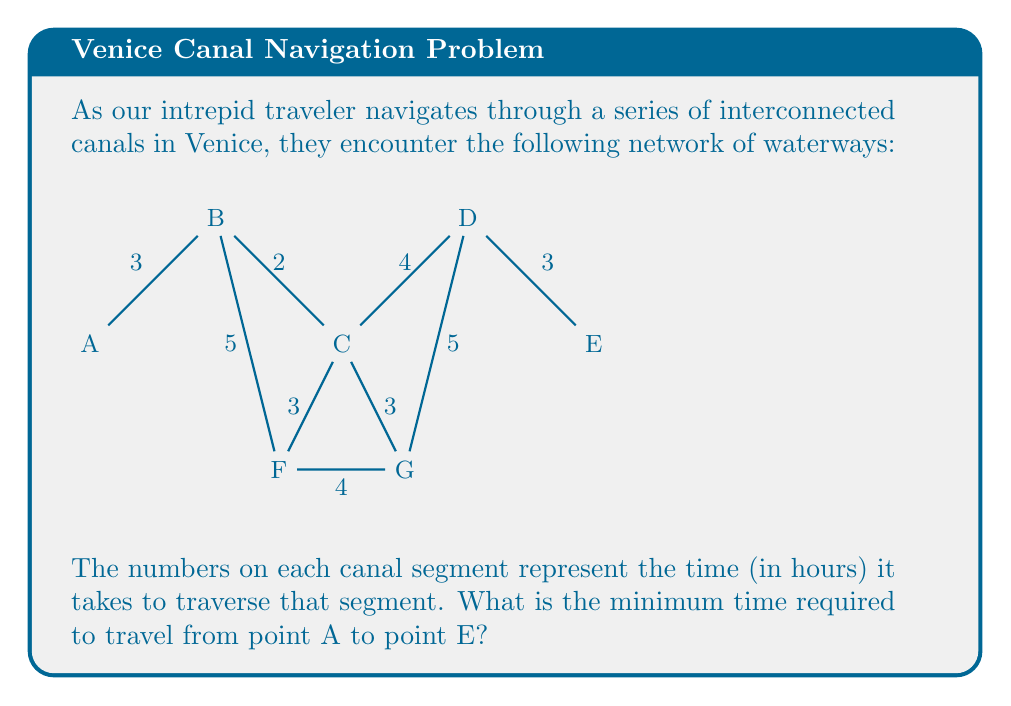Can you solve this math problem? To solve this problem, we need to find the shortest path from A to E. We can use Dijkstra's algorithm or simply evaluate all possible paths:

1) Path A-B-C-D-E: 
   $$3 + 2 + 4 + 3 = 12$$ hours

2) Path A-B-F-G-D-E: 
   $$3 + 5 + 4 + 5 + 3 = 20$$ hours

3) Path A-B-C-F-G-D-E: 
   $$3 + 2 + 3 + 4 + 5 + 3 = 20$$ hours

4) Path A-B-C-G-D-E: 
   $$3 + 2 + 3 + 5 + 3 = 16$$ hours

The shortest path is A-B-C-D-E, taking 12 hours.

To verify, we can check if there's a shorter path through F or G:

5) A-B-F-C-D-E: 
   $$3 + 5 + 3 + 4 + 3 = 18$$ hours (longer than the shortest)

6) A-B-C-F-D-E or A-B-C-G-D-E: 
   Both would be longer than A-B-C-D-E as they add an extra segment.

Therefore, the minimum time required is 12 hours via the path A-B-C-D-E.
Answer: 12 hours 